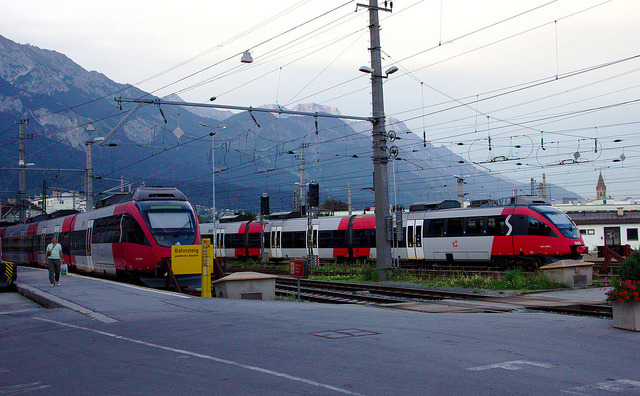Can you describe the setting surrounding the trains? The image depicts a train station set against a backdrop of beautiful mountains. It's likely to be in a valley, given the presence of the mountains in close proximity. The area around the station seems to be well-maintained, with neat tracks and structured overhead lines, which are characteristic of an efficient public transport system. What time of day does it appear to be in the photo? It seems to be daytime with overcast weather, as the outdoor light is bright yet diffuse, and no strong shadows are visible on the ground. 